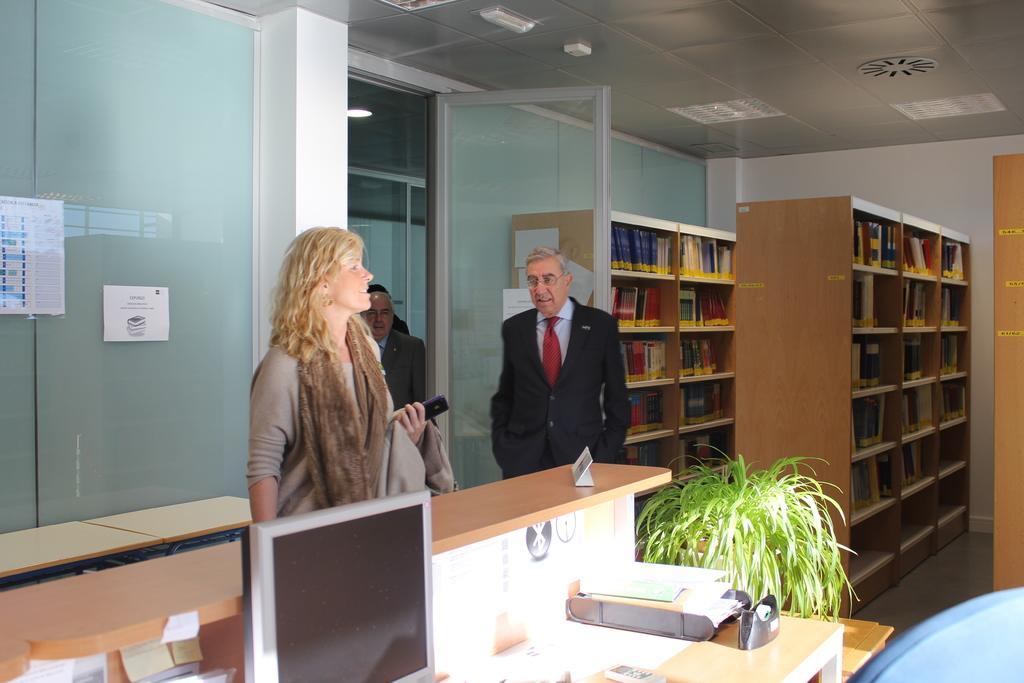In one or two sentences, can you explain what this image depicts? In this picture there is a woman and a man standing. In front of a desk, there is a monitor, plant, placed on the table. In the background there is a shelf in which some books were placed. And we can observe a wall here. 